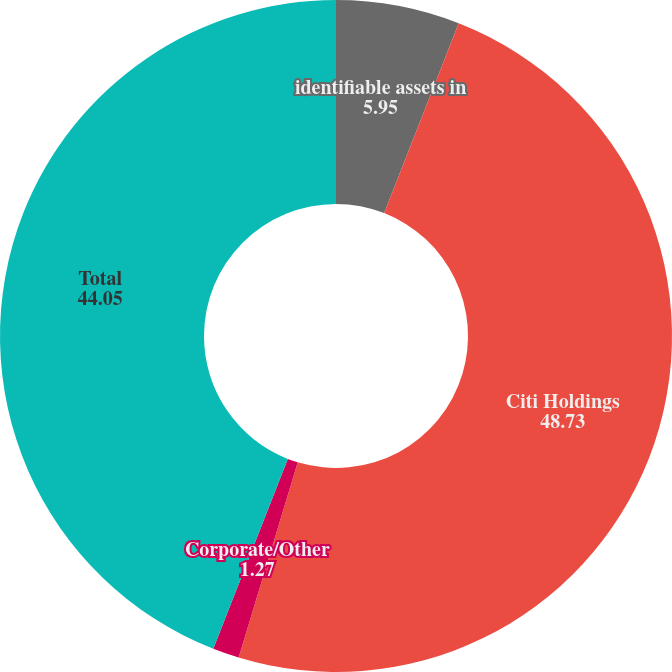<chart> <loc_0><loc_0><loc_500><loc_500><pie_chart><fcel>identifiable assets in<fcel>Citi Holdings<fcel>Corporate/Other<fcel>Total<nl><fcel>5.95%<fcel>48.73%<fcel>1.27%<fcel>44.05%<nl></chart> 